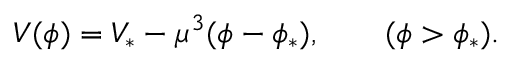<formula> <loc_0><loc_0><loc_500><loc_500>V ( \phi ) = V _ { \ast } - \mu ^ { 3 } ( \phi - \phi _ { \ast } ) , \quad ( \phi > \phi _ { \ast } ) .</formula> 